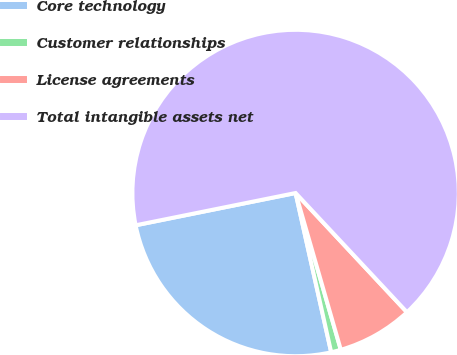Convert chart. <chart><loc_0><loc_0><loc_500><loc_500><pie_chart><fcel>Core technology<fcel>Customer relationships<fcel>License agreements<fcel>Total intangible assets net<nl><fcel>25.33%<fcel>0.97%<fcel>7.49%<fcel>66.21%<nl></chart> 